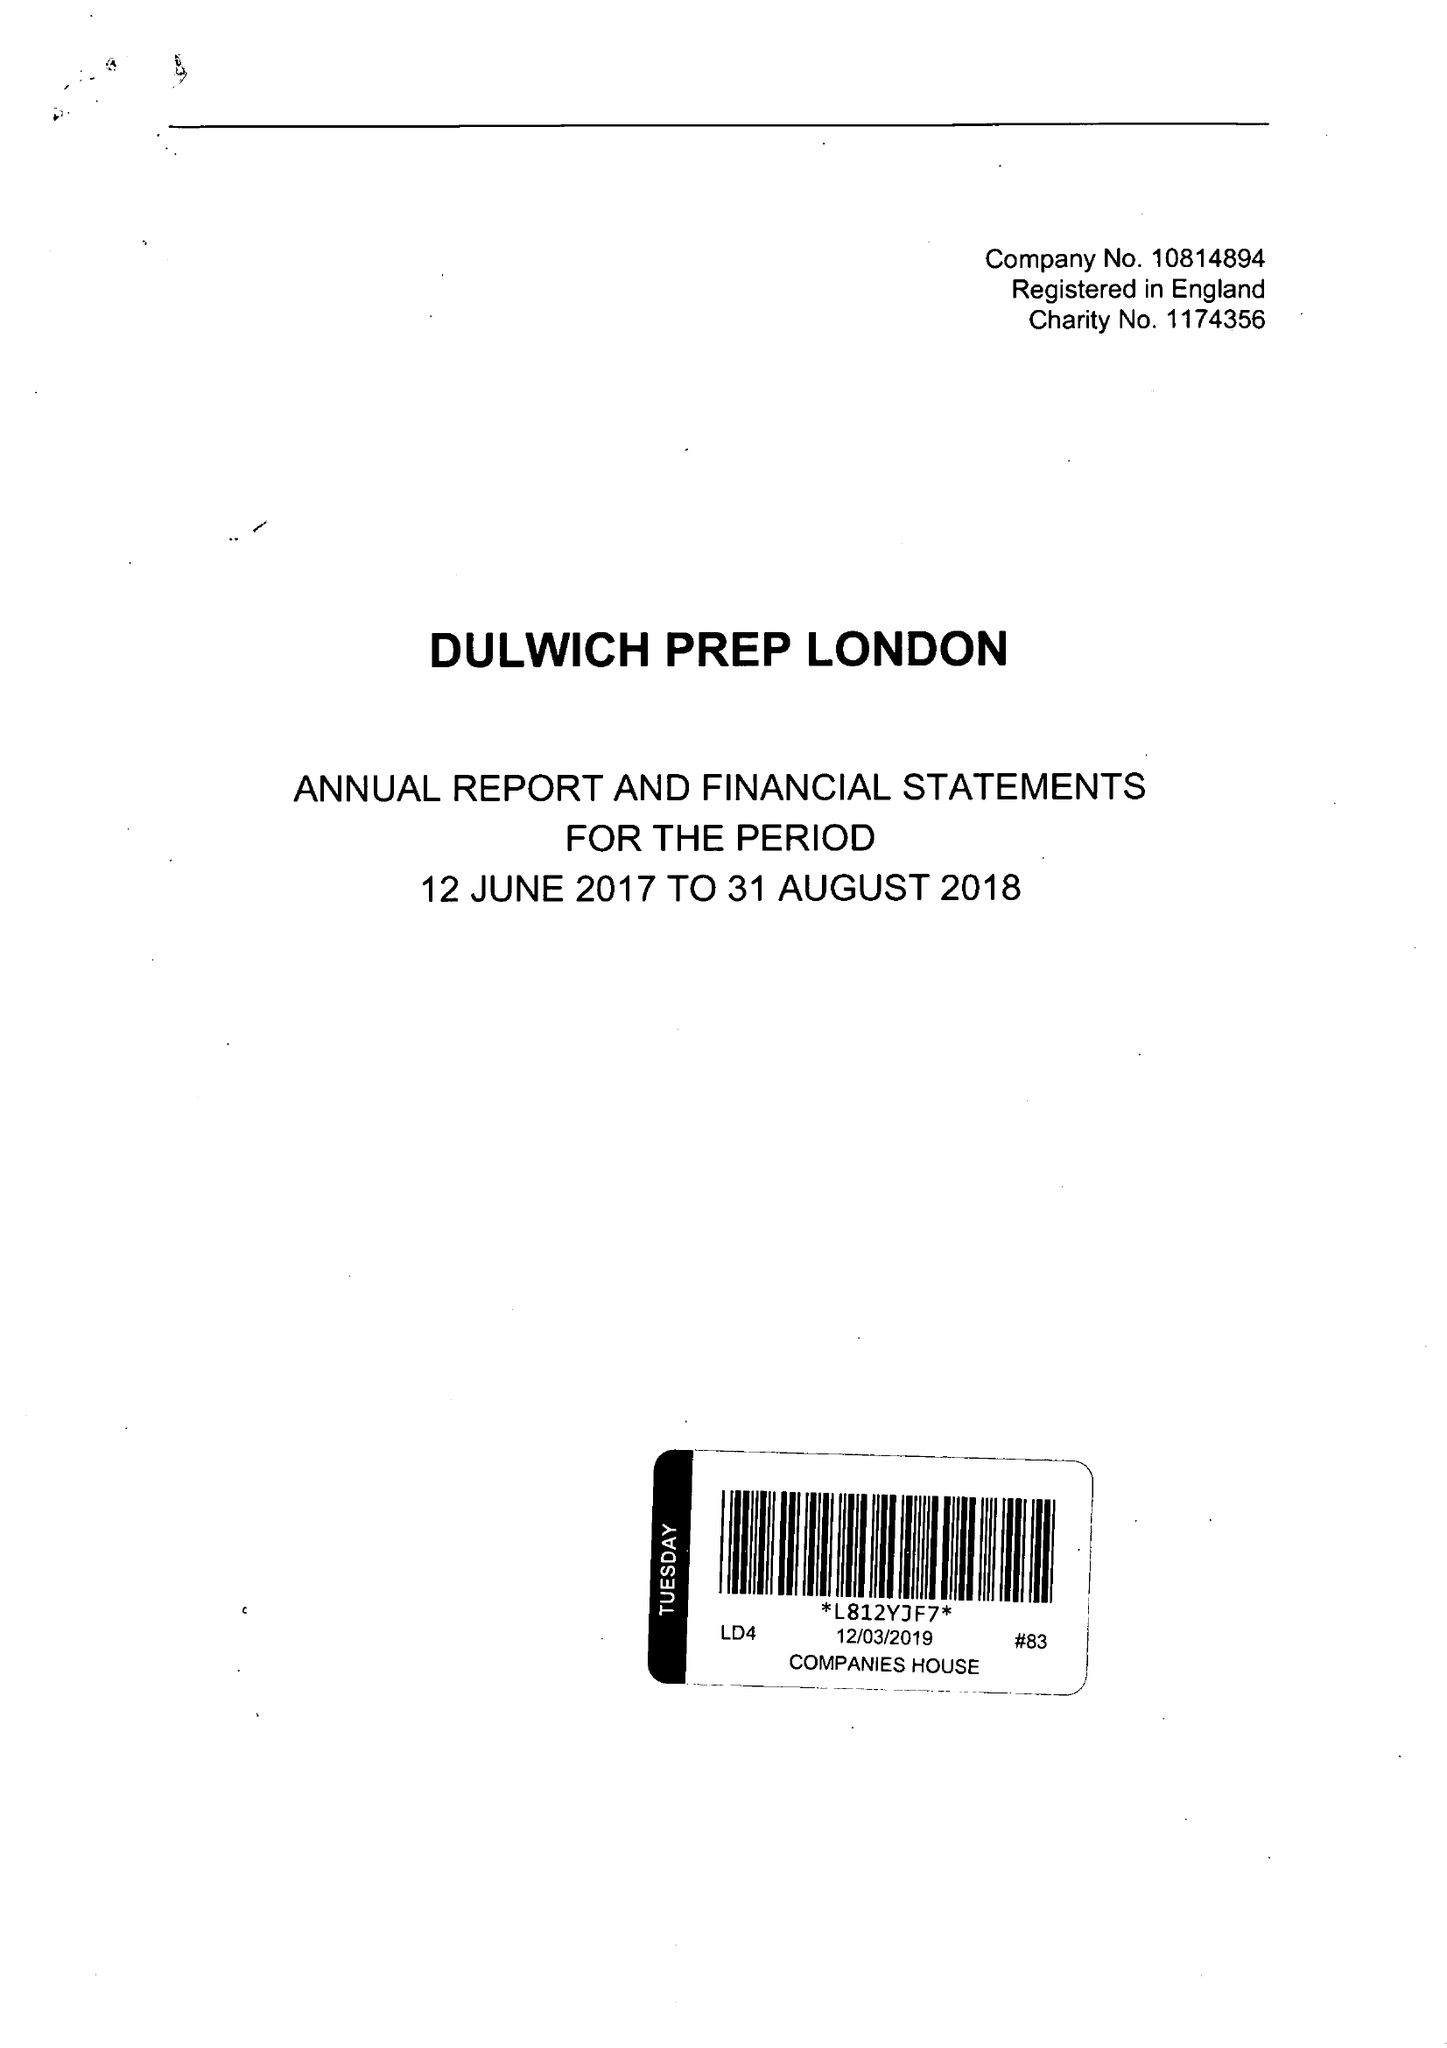What is the value for the charity_name?
Answer the question using a single word or phrase. Dulwich Prep London 